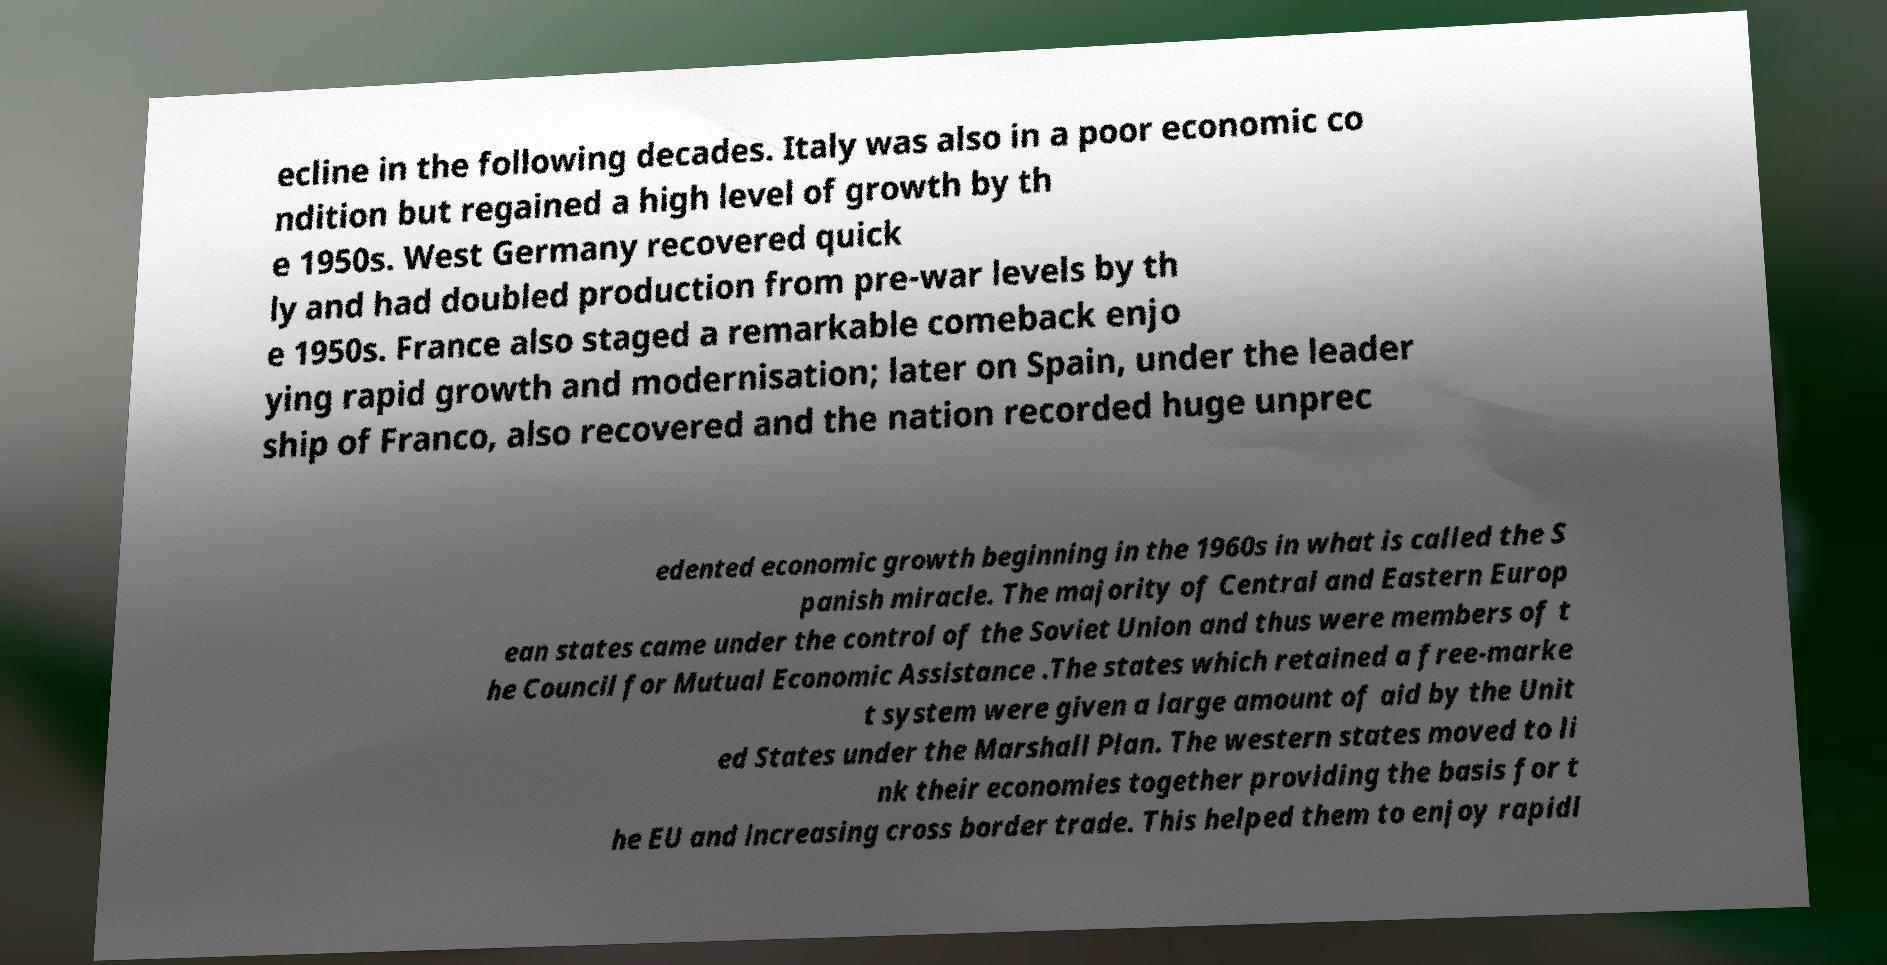Please read and relay the text visible in this image. What does it say? ecline in the following decades. Italy was also in a poor economic co ndition but regained a high level of growth by th e 1950s. West Germany recovered quick ly and had doubled production from pre-war levels by th e 1950s. France also staged a remarkable comeback enjo ying rapid growth and modernisation; later on Spain, under the leader ship of Franco, also recovered and the nation recorded huge unprec edented economic growth beginning in the 1960s in what is called the S panish miracle. The majority of Central and Eastern Europ ean states came under the control of the Soviet Union and thus were members of t he Council for Mutual Economic Assistance .The states which retained a free-marke t system were given a large amount of aid by the Unit ed States under the Marshall Plan. The western states moved to li nk their economies together providing the basis for t he EU and increasing cross border trade. This helped them to enjoy rapidl 